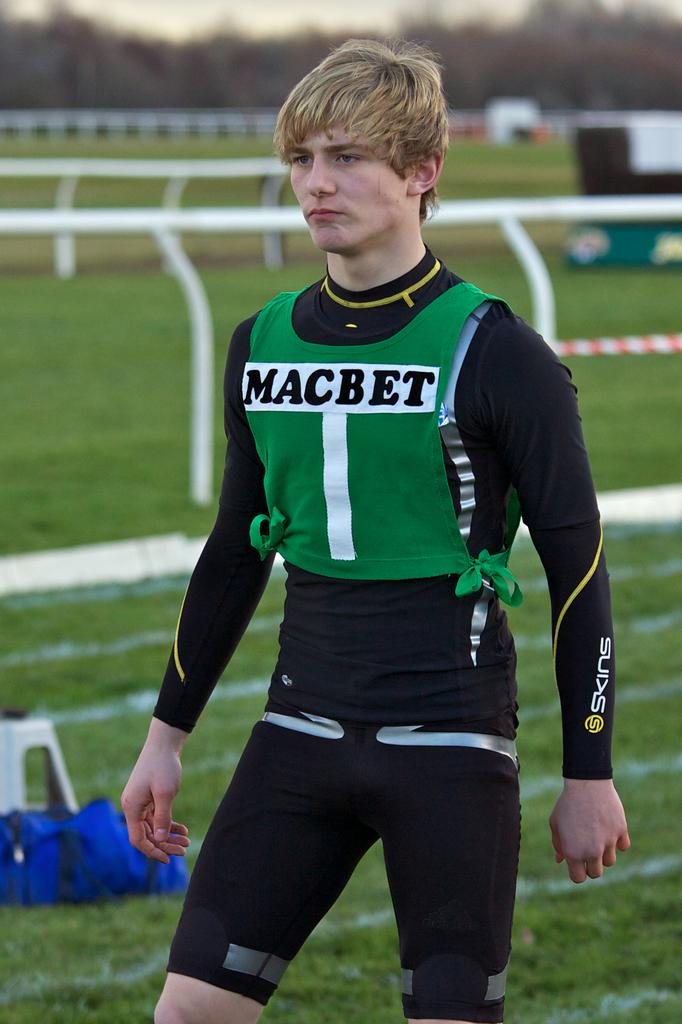What is the main subject of the image? There is a man standing in the image. What is on the ground near the man? There is a bag on the ground in the image. What type of surface is the man standing on? There is grass on the ground in the image. What can be seen in the distance in the image? There are trees visible in the background of the image. Is there a volcano erupting in the background of the image? No, there is no volcano present in the image. What type of power is the man generating in the image? There is no indication of the man generating any power in the image. 